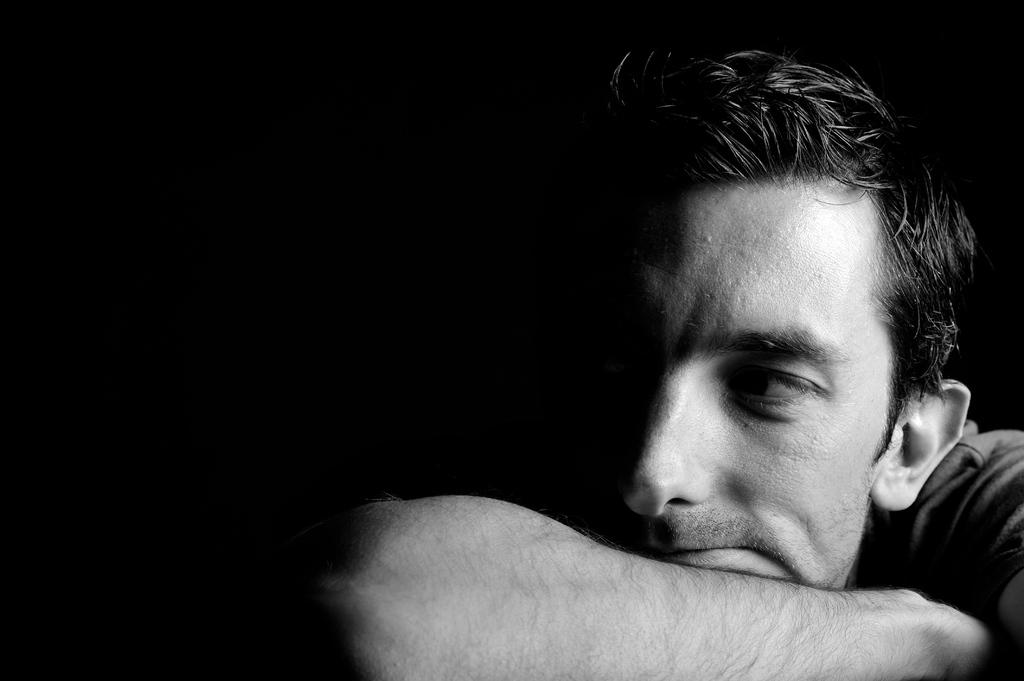What is the color of the background in the image? The background of the image is dark. Can you describe the main subject in the image? There is a man in the picture. What direction is the clam facing in the image? There is no clam present in the image. Does the man have a pet in the image? The provided facts do not mention a pet, so we cannot determine if the man has a pet in the image. 